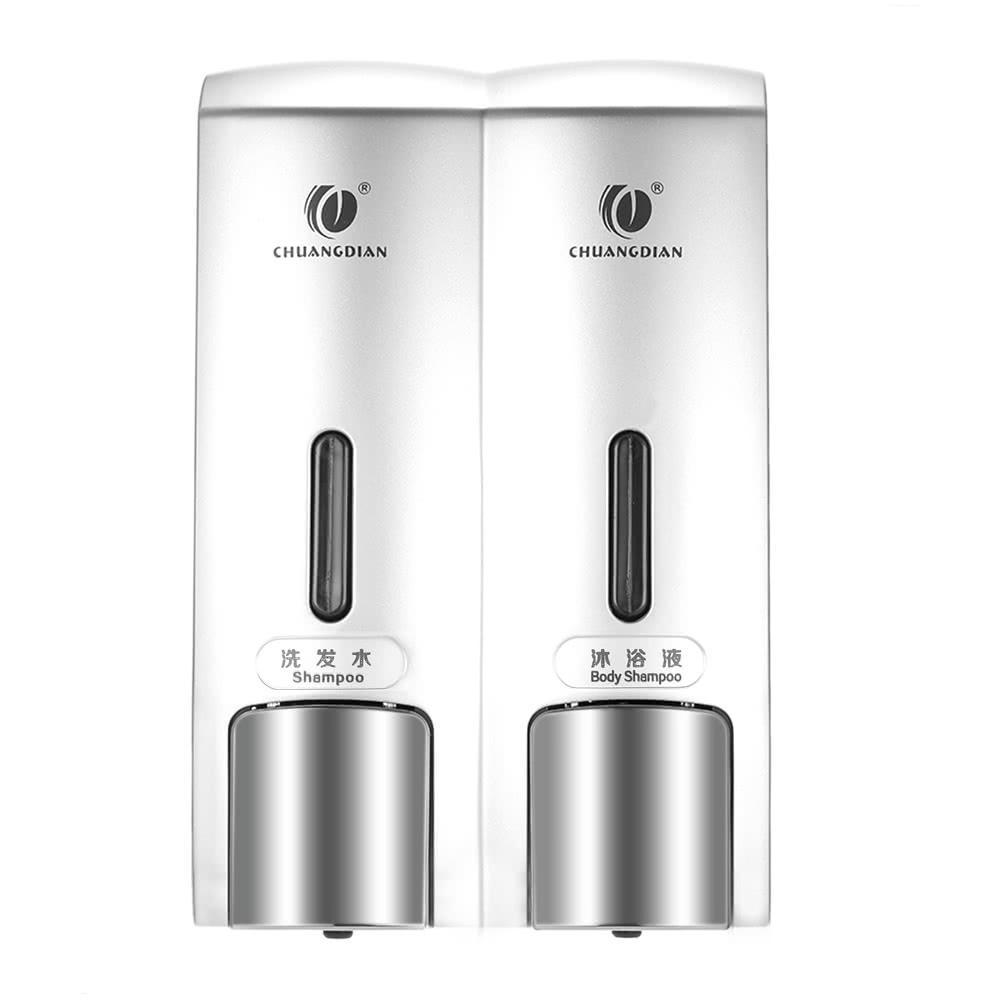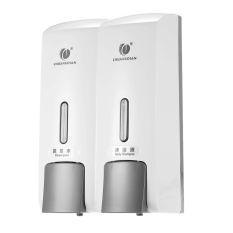The first image is the image on the left, the second image is the image on the right. For the images shown, is this caption "At least one dispenser is filled with a colored, non-white substance and dispenses more than one substance." true? Answer yes or no. No. The first image is the image on the left, the second image is the image on the right. Assess this claim about the two images: "The right image shows a soap dispenser that has both yellow and green liquid visible in separate compartments". Correct or not? Answer yes or no. No. 